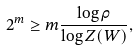Convert formula to latex. <formula><loc_0><loc_0><loc_500><loc_500>2 ^ { m } \geq m \frac { \log \rho } { \log Z ( W ) } ,</formula> 